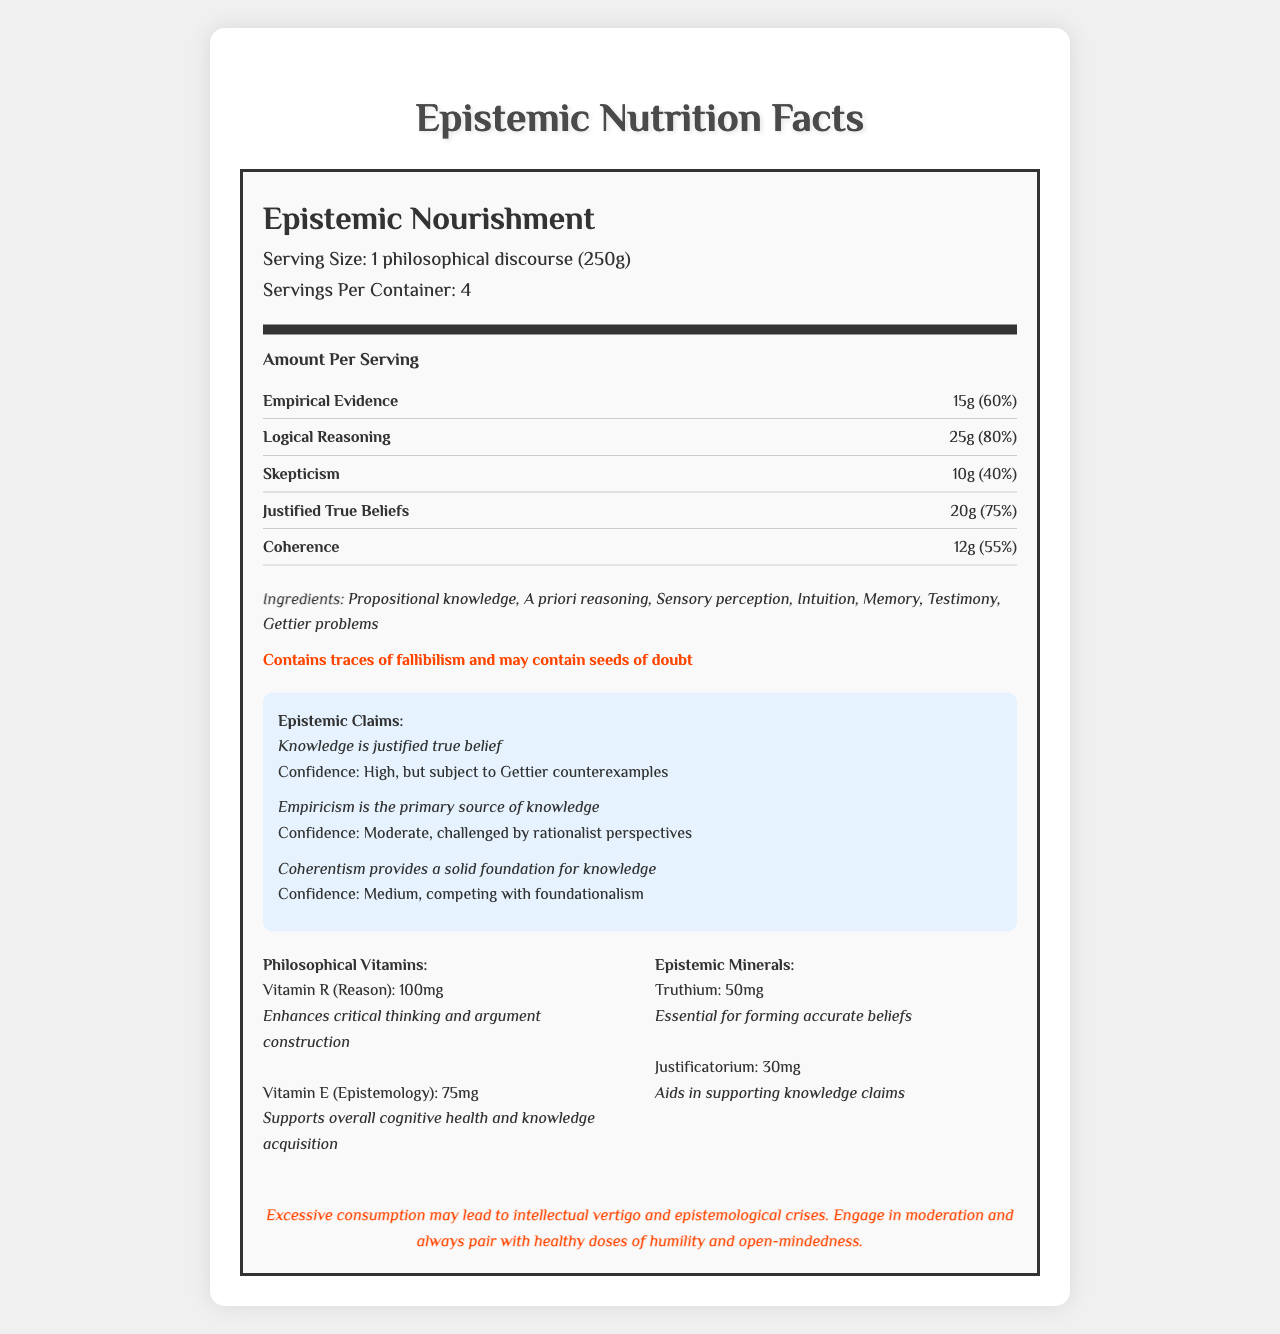what is the product name? The product name is clearly stated at the top of the document within the nutrition title section.
Answer: Epistemic Nourishment what is the serving size for Epistemic Nourishment? The serving size is given right below the nutrition title as "1 philosophical discourse (250g)".
Answer: 1 philosophical discourse (250g) what is the daily value of Logical Reasoning per serving? The daily value of Logical Reasoning per serving is listed as 80% under the Amount Per Serving section.
Answer: 80% what are the ingredients listed for this product? The ingredients are listed in a specific section labeled "Ingredients".
Answer: Propositional knowledge, A priori reasoning, Sensory perception, Intuition, Memory, Testimony, Gettier problems what allergens might this product contain? The allergen information is clearly stated in bold.
Answer: Contains traces of fallibilism and may contain seeds of doubt what is the confidence level for the claim "Knowledge is justified true belief"? The confidence level is provided next to the epistemic claim about justified true beliefs.
Answer: High, but subject to Gettier counterexamples which nutrient has the highest daily value percentage in this product? A. Empirical Evidence B. Logical Reasoning C. Skepticism D. Justified True Beliefs Logical Reasoning has a daily value of 80%, which is higher than the other nutrients listed.
Answer: B. Logical Reasoning which philosophical vitamin is mentioned along with a benefit related to cognitive health? A. Vitamin R B. Vitamin E Vitamin E (Epistemology) is mentioned as supporting overall cognitive health and knowledge acquisition.
Answer: B. Vitamin E is "Empiricism is the primary source of knowledge" considered incontrovertible in this document? The document states the confidence level as moderate for this claim, indicating it's challenged by rationalist perspectives.
Answer: No describe the main idea of the document The document mimics a traditional Nutrition Facts label but replaces standard nutritional information with philosophical and epistemological concepts. It humorously explores the different elements that contribute to knowledge and critical thinking.
Answer: The document is a satirical Nutrition Facts label for "Epistemic Nourishment", presenting philosophical concepts as nutritional information. It includes details on serving size, nutrients, ingredients, allergen information, epistemic claims, and philosophical vitamins and minerals, highlighting the complexities and debates within epistemology. what is the essential mineral for forming accurate beliefs according to the document? The document lists Truthium as essential for forming accurate beliefs under epistemic minerals.
Answer: Truthium can we determine the precise manufacturing process of Epistemic Nourishment from this document? The document provides information on the philosophical components and nutrients but does not detail the manufacturing process.
Answer: Not enough information what is the suggested consumption advice to avoid negative effects? The warning section advises moderation and pairing with humility and open-mindedness to avoid intellectual vertigo and epistemological crises.
Answer: Engage in moderation and always pair with healthy doses of humility and open-mindedness. 